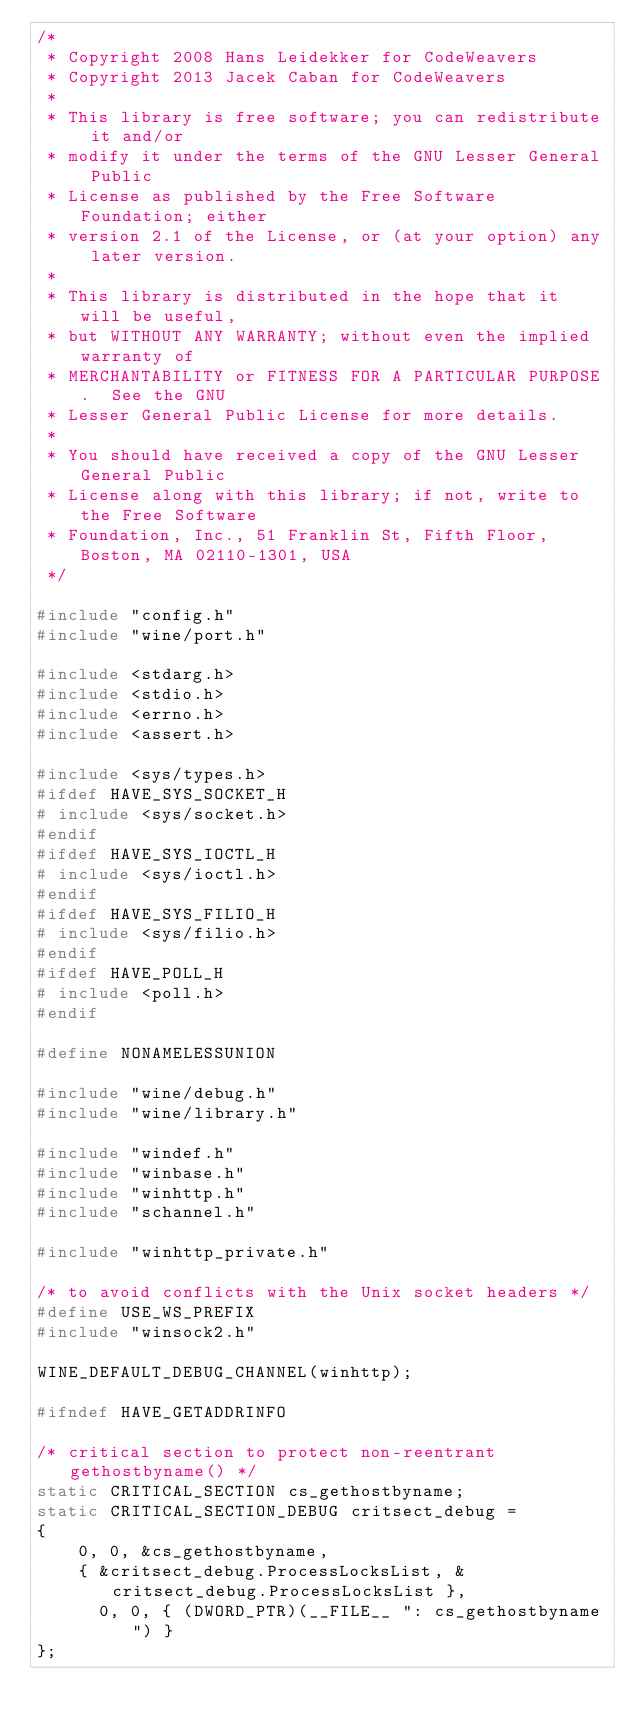<code> <loc_0><loc_0><loc_500><loc_500><_C_>/*
 * Copyright 2008 Hans Leidekker for CodeWeavers
 * Copyright 2013 Jacek Caban for CodeWeavers
 *
 * This library is free software; you can redistribute it and/or
 * modify it under the terms of the GNU Lesser General Public
 * License as published by the Free Software Foundation; either
 * version 2.1 of the License, or (at your option) any later version.
 *
 * This library is distributed in the hope that it will be useful,
 * but WITHOUT ANY WARRANTY; without even the implied warranty of
 * MERCHANTABILITY or FITNESS FOR A PARTICULAR PURPOSE.  See the GNU
 * Lesser General Public License for more details.
 *
 * You should have received a copy of the GNU Lesser General Public
 * License along with this library; if not, write to the Free Software
 * Foundation, Inc., 51 Franklin St, Fifth Floor, Boston, MA 02110-1301, USA
 */

#include "config.h"
#include "wine/port.h"

#include <stdarg.h>
#include <stdio.h>
#include <errno.h>
#include <assert.h>

#include <sys/types.h>
#ifdef HAVE_SYS_SOCKET_H
# include <sys/socket.h>
#endif
#ifdef HAVE_SYS_IOCTL_H
# include <sys/ioctl.h>
#endif
#ifdef HAVE_SYS_FILIO_H
# include <sys/filio.h>
#endif
#ifdef HAVE_POLL_H
# include <poll.h>
#endif

#define NONAMELESSUNION

#include "wine/debug.h"
#include "wine/library.h"

#include "windef.h"
#include "winbase.h"
#include "winhttp.h"
#include "schannel.h"

#include "winhttp_private.h"

/* to avoid conflicts with the Unix socket headers */
#define USE_WS_PREFIX
#include "winsock2.h"

WINE_DEFAULT_DEBUG_CHANNEL(winhttp);

#ifndef HAVE_GETADDRINFO

/* critical section to protect non-reentrant gethostbyname() */
static CRITICAL_SECTION cs_gethostbyname;
static CRITICAL_SECTION_DEBUG critsect_debug =
{
    0, 0, &cs_gethostbyname,
    { &critsect_debug.ProcessLocksList, &critsect_debug.ProcessLocksList },
      0, 0, { (DWORD_PTR)(__FILE__ ": cs_gethostbyname") }
};</code> 